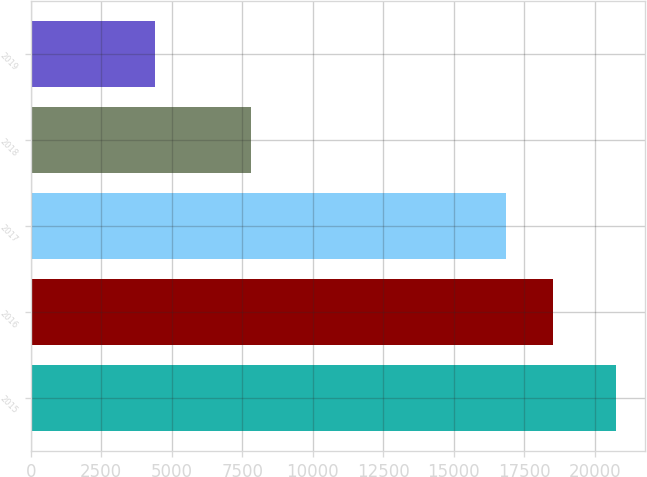<chart> <loc_0><loc_0><loc_500><loc_500><bar_chart><fcel>2015<fcel>2016<fcel>2017<fcel>2018<fcel>2019<nl><fcel>20764<fcel>18510.9<fcel>16874<fcel>7818<fcel>4395<nl></chart> 